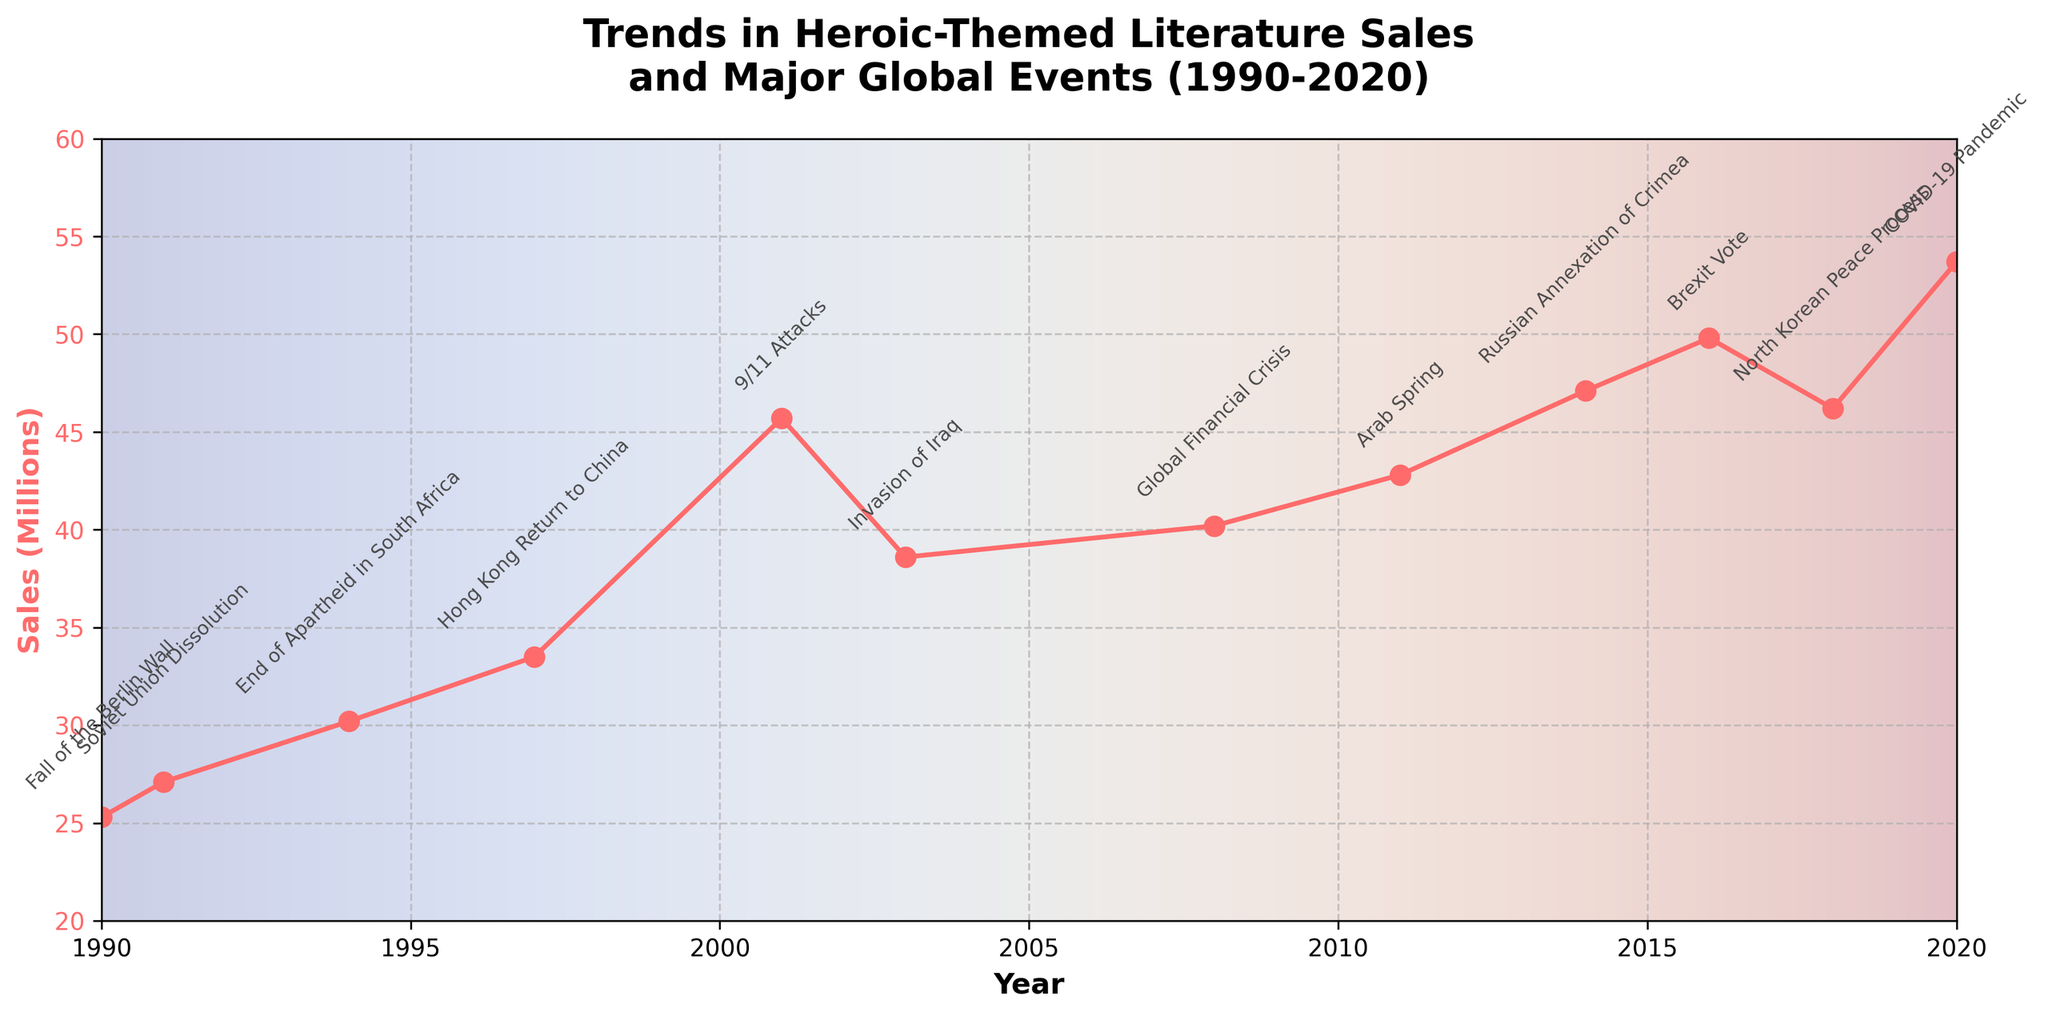what is the title of the plot? The title is usually located at the top of the plot and provides an overview or summary of what the plot represents. Here, it reads "Trends in Heroic-Themed Literature Sales and Major Global Events (1990-2020)."
Answer: Trends in Heroic-Themed Literature Sales and Major Global Events (1990-2020) What is the trend of heroic-themed literature sales over the period from 1990 to 2020? By observing the plot, we can see that the sales figures shown by the red line generally increase over the given time period. Starting from around 25.3 million in 1990, it reaches 53.7 million by 2020. Despite some fluctuations, the overall trend is upward.
Answer: Increasing What event coincides with the sharpest rise in sales? By examining the steeper sections of the graph and correlating it with the annotations, it's noticeable that the sharpest rise in sales occurs around the year 2001, which is marked as the 9/11 Attacks.
Answer: 9/11 Attacks During which years do we observe a decline in the sales of heroic-themed literature? By looking for downward slopes in the graph, we can spot declines from 2001 to 2003 and from 2016 to 2018.
Answer: 2001 to 2003 and 2016 to 2018 How do the sales in 1990 compare to sales in 2020? The plot shows that sales in 1990 were around 25.3 million, while in 2020 they were 53.7 million. By subtracting, the increase in sales is 53.7 - 25.3 = 28.4 million.
Answer: 28.4 million increase What is the average sales of heroic-themed literature over the entire period? To find the average, sum up all the sales figures and divide by the number of years. The sum of sales (25.3+27.1+30.2+33.5+45.7+38.6+40.2+42.8+47.1+49.8+46.2+53.7) = 480.2 million. Divide by the number of years (12): 480.2 / 12 = 40.0 million.
Answer: 40.0 million What were the sales figures in the year of the Global Financial Crisis (2008)? By finding the year 2008 on the x-axis and referring to the corresponding value on the graph, the sales figure is 40.2 million.
Answer: 40.2 million How did the sales change between the Arab Spring (2011) and Brexit Vote (2016)? Arab Spring sales in 2011 were 42.8 million, and Brexit Vote sales in 2016 were 49.8 million. The difference is 49.8 - 42.8 = 7.0 million.
Answer: 7.0 million increase What is the impact of 9/11 Attacks on heroic-themed literature sales? By observing the data point for the year 2001 (45.7 million) and comparing it to the previous year's value in 1997 (33.5 million), there is a significant increase of 45.7 - 33.5 = 12.2 million.
Answer: 12.2 million increase Which year has the highest sale of heroic-themed literature, and what event occurred that year? By identifying the highest point on the graph, we can see it occurs in 2020 with 53.7 million in sales, during the COVID-19 Pandemic.
Answer: 2020, COVID-19 Pandemic 